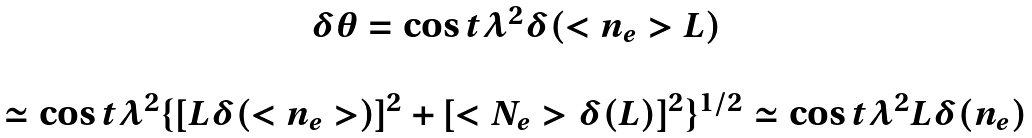Convert formula to latex. <formula><loc_0><loc_0><loc_500><loc_500>\begin{array} { c } \delta \theta = \cos t \lambda ^ { 2 } \delta ( < n _ { e } > L ) \\ \\ \simeq \cos t \lambda ^ { 2 } \{ [ L \delta ( < n _ { e } > ) ] ^ { 2 } + [ < N _ { e } > \delta ( L ) ] ^ { 2 } \} ^ { 1 / 2 } \simeq \cos t \lambda ^ { 2 } L \delta ( n _ { e } ) \end{array}</formula> 